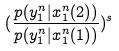Convert formula to latex. <formula><loc_0><loc_0><loc_500><loc_500>( \frac { p ( y _ { 1 } ^ { n } | x _ { 1 } ^ { n } ( 2 ) ) } { p ( y _ { 1 } ^ { n } | x _ { 1 } ^ { n } ( 1 ) ) } ) ^ { s }</formula> 